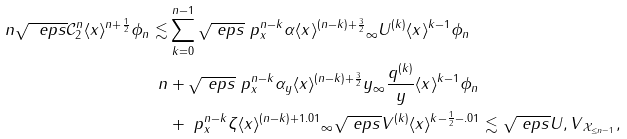<formula> <loc_0><loc_0><loc_500><loc_500>\ n \| \sqrt { \ e p s } \mathcal { C } _ { 2 } ^ { n } \langle x \rangle ^ { n + \frac { 1 } { 2 } } \phi _ { n } \| \lesssim & \sum _ { k = 0 } ^ { n - 1 } \sqrt { \ e p s } \| \ p _ { x } ^ { n - k } \alpha \langle x \rangle ^ { ( n - k ) + \frac { 3 } { 2 } } \| _ { \infty } \| U ^ { ( k ) } \langle x \rangle ^ { k - 1 } \phi _ { n } \| \\ \ n & + \sqrt { \ e p s } \| \ p _ { x } ^ { n - k } \alpha _ { y } \langle x \rangle ^ { ( n - k ) + \frac { 3 } { 2 } } y \| _ { \infty } \| \frac { q ^ { ( k ) } } { y } \langle x \rangle ^ { k - 1 } \phi _ { n } \| \\ & + \| \ p _ { x } ^ { n - k } \zeta \langle x \rangle ^ { ( n - k ) + 1 . 0 1 } \| _ { \infty } \| \sqrt { \ e p s } V ^ { ( k ) } \langle x \rangle ^ { k - \frac { 1 } { 2 } - . 0 1 } \| \lesssim \sqrt { \ e p s } \| U , V \| _ { \mathcal { X } _ { \leq n - 1 } } ,</formula> 